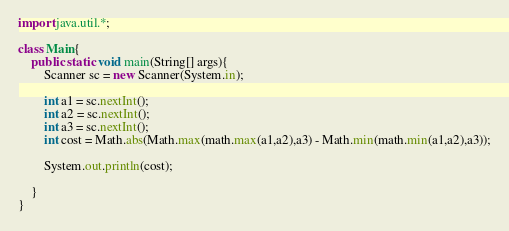Convert code to text. <code><loc_0><loc_0><loc_500><loc_500><_Java_>import java.util.*;

class Main{
	public static void main(String[] args){
		Scanner sc = new Scanner(System.in);
		
		int a1 = sc.nextInt();
		int a2 = sc.nextInt();
		int a3 = sc.nextInt();
		int cost = Math.abs(Math.max(math.max(a1,a2),a3) - Math.min(math.min(a1,a2),a3));

		System.out.println(cost);

	}
}</code> 